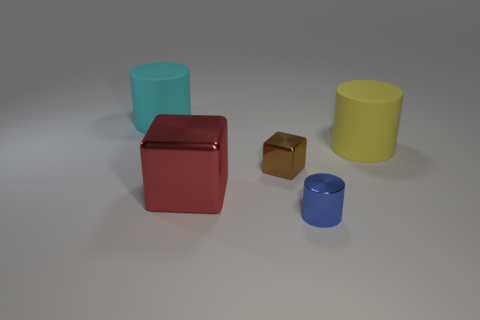Subtract all shiny cylinders. How many cylinders are left? 2 Add 2 blue things. How many objects exist? 7 Subtract all cyan cylinders. How many cylinders are left? 2 Subtract all blocks. How many objects are left? 3 Subtract all green cylinders. Subtract all red cubes. How many cylinders are left? 3 Add 2 cyan things. How many cyan things are left? 3 Add 3 big cylinders. How many big cylinders exist? 5 Subtract 1 red cubes. How many objects are left? 4 Subtract all small red metallic cubes. Subtract all tiny blue cylinders. How many objects are left? 4 